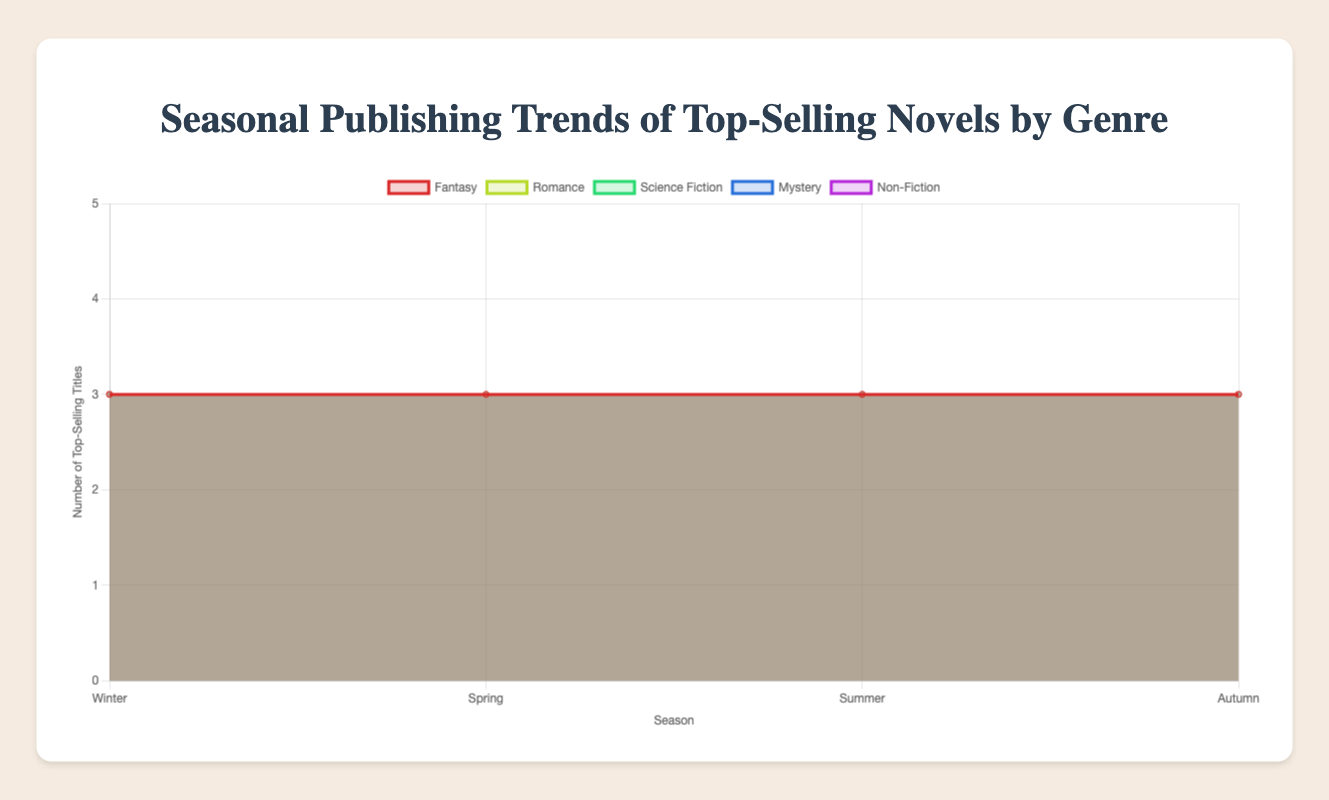What genre shows the most consistent number of top-selling titles across all seasons? Looking at the plot, identify which genre has about the same number of top-selling titles in each season by comparing the values on the y-axis for Winter, Spring, Summer, and Autumn within each genre.
Answer: Science Fiction Which season has the highest number of top-selling Romance titles? Observe the peak value for the Romance curve across the four seasons and note which season's data point is the highest.
Answer: Spring Compare the number of top-selling Mystery titles in Winter and Autumn. Which season has more? Locate the Mystery curve and compare the y-axis values at Winter and Autumn.
Answer: Winter How many top-selling Fantasy titles are published in Spring and Summer combined? Look at the data points for Fantasy during Spring and Summer and sum their values.
Answer: 6 In which season does Non-Fiction have the fewest top-selling titles? Find the minimum y-axis value for Non-Fiction across the four seasons.
Answer: Autumn Compare the number of top-selling titles for Mystery and Romance in Summer. Which genre has fewer? Locate the data points for Mystery and Romance in Summer and compare their y-axis values.
Answer: Mystery What is the sum of top-selling titles for Science Fiction across all four seasons? Add the y-axis values for Science Fiction in Winter, Spring, Summer, and Autumn.
Answer: 12 Which genre has the greatest fluctuation in the number of top-selling titles across the seasons? Compare the range (max value minus min value) of the number of top-selling titles for each genre.
Answer: Romance What is the difference in the number of top-selling Non-Fiction titles between Spring and Winter? Subtract the y-axis value for Winter from the y-axis value for Spring for Non-Fiction.
Answer: 1 Which season appears most frequently as the peak publication period across all genres? For each genre, determine the peak season and count the occurrences of each season being the peak.
Answer: Summer 